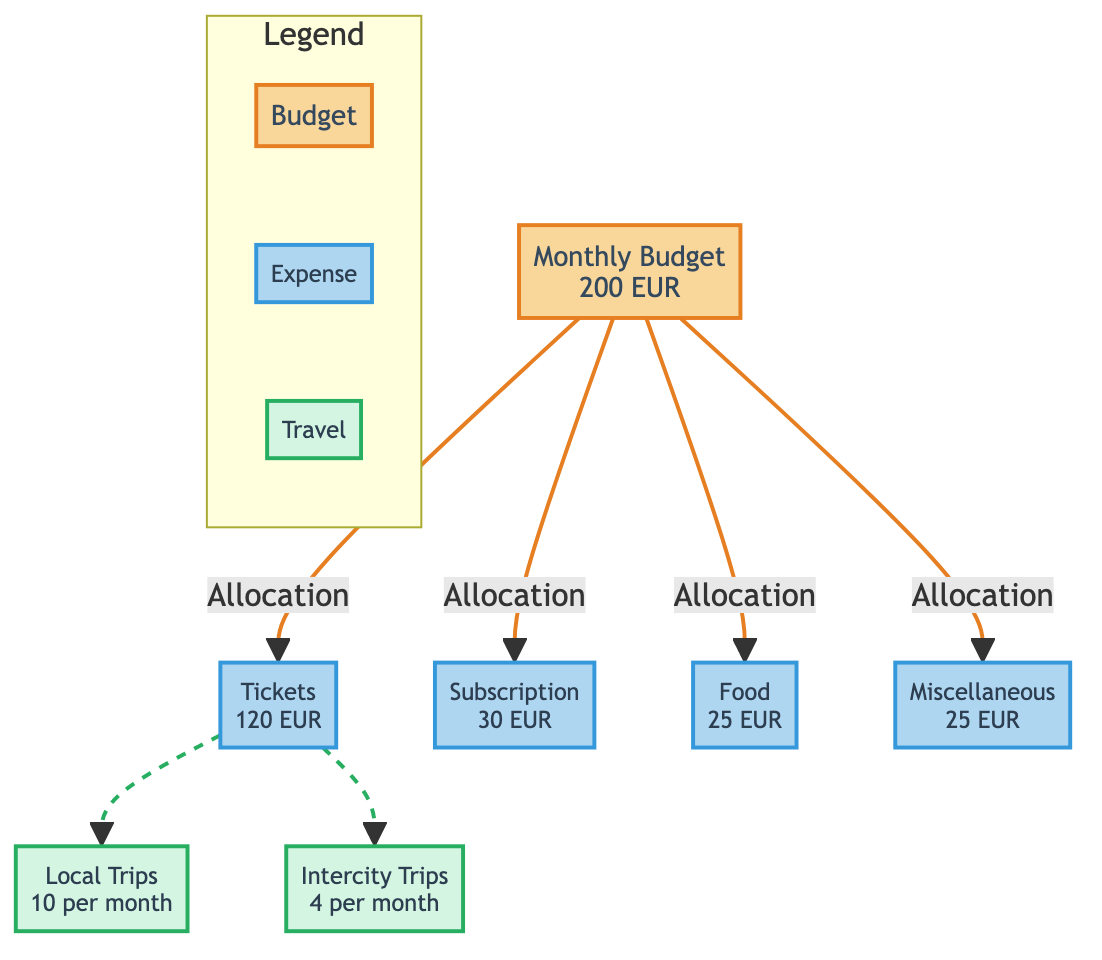What is the total monthly budget for train travel? The diagram specifies the total monthly budget for train travel at the top, under the Monthly Budget node, which is 200 EUR.
Answer: 200 EUR How much does the subscription cost? Under the Expenses section, the Subscription node provides the cost of 30 EUR.
Answer: 30 EUR What is the monthly expense for tickets? The Tickets node under Expenses displays the amount allocated for tickets, which is 120 EUR.
Answer: 120 EUR How many local trips are budgeted per month? The Local Trips node under Travel Frequency states the frequency number, which is 10 per month.
Answer: 10 What is the total amount allocated for Food and Miscellaneous combined? To find the total, add the amounts from the Food and Miscellaneous nodes: 25 EUR (Food) + 25 EUR (Miscellaneous) = 50 EUR.
Answer: 50 EUR Which category has the highest expense? By comparing the expense amounts shown in the diagram, Tickets at 120 EUR is the highest among them (Subscription, Food, and Miscellaneous).
Answer: Tickets How many intercity trips does the budget allow for each month? Referring to the Intercity Trips node under Travel Frequency, it is stated as 4 trips per month.
Answer: 4 What percentage of the total budget is allocated for the Subscription? Calculate the percentage as (30 EUR Subscription / 200 EUR Total Budget) * 100 = 15%.
Answer: 15% How many nodes represent the types of travel? There are two nodes representing the types of travel: Local Trips and Intercity Trips.
Answer: 2 